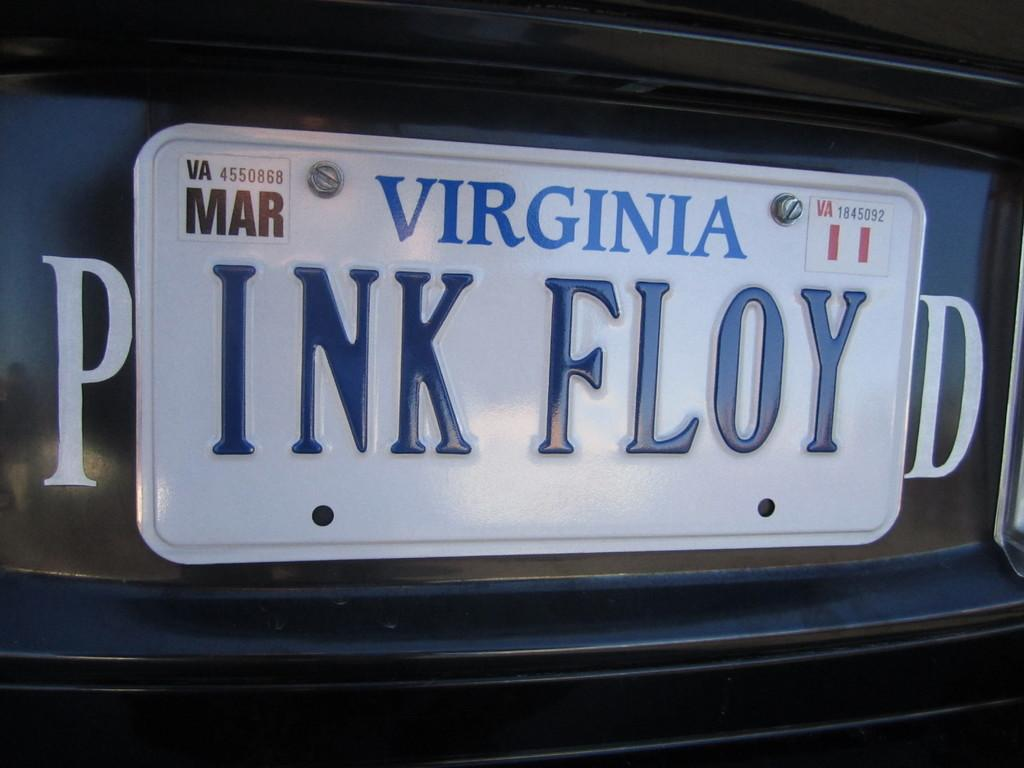<image>
Offer a succinct explanation of the picture presented. A virginia license plate with the letters INK FLOY on it 